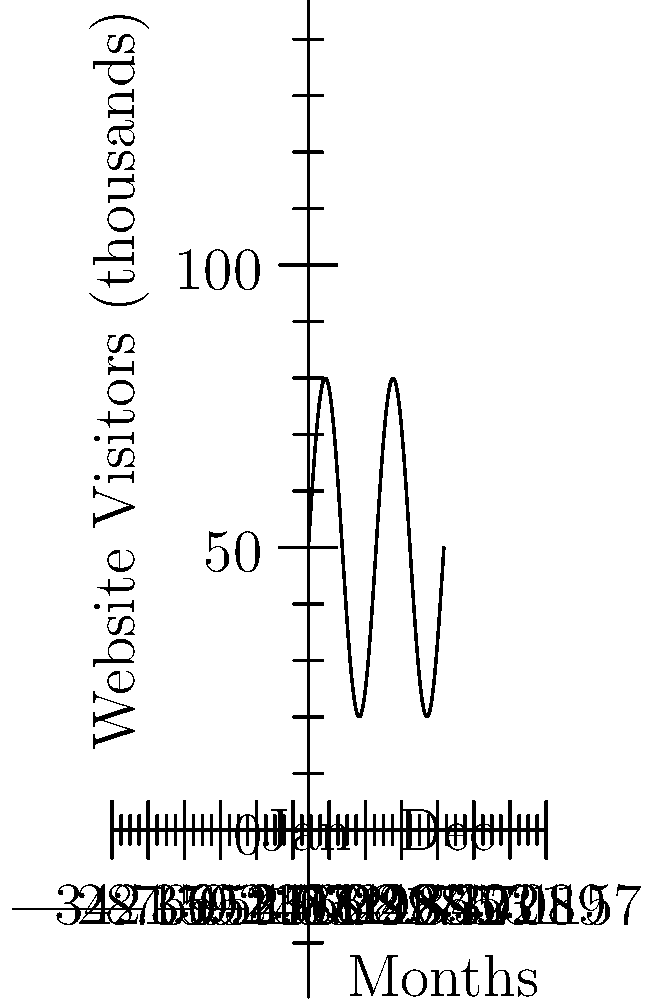The graph shows the monthly website traffic for your guesthouse over a year. If the pattern continues, which month is likely to have the highest number of visitors, assuming January is month 0? To determine the month with the highest number of visitors, we need to analyze the sinusoidal pattern in the graph:

1. The graph shows a complete cycle over 12 months, with two peak periods.
2. The sine function in the graph is of the form $f(x) = A \sin(\frac{2\pi}{P}x) + B$, where:
   - $A$ is the amplitude (half the distance between peak and trough)
   - $P$ is the period (12 months)
   - $B$ is the vertical shift (average number of visitors)
3. The peaks occur when $\sin(\frac{2\pi}{P}x)$ equals 1, which happens when $\frac{2\pi}{P}x = \frac{\pi}{2} + 2\pi n$, where $n$ is an integer.
4. Solving for $x$: $x = \frac{P}{4} + \frac{P}{2}n = 3 + 6n$ (months)
5. The first peak occurs at 3 months (April), and the second at 9 months (October).
6. Since the graph starts at January (month 0), the highest point corresponds to July (month 6).

Therefore, assuming the pattern continues, July (month 6) is likely to have the highest number of visitors.
Answer: July (month 6) 